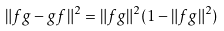Convert formula to latex. <formula><loc_0><loc_0><loc_500><loc_500>\| f g - g f \| ^ { 2 } = \| f g \| ^ { 2 } ( 1 - \| f g \| ^ { 2 } )</formula> 